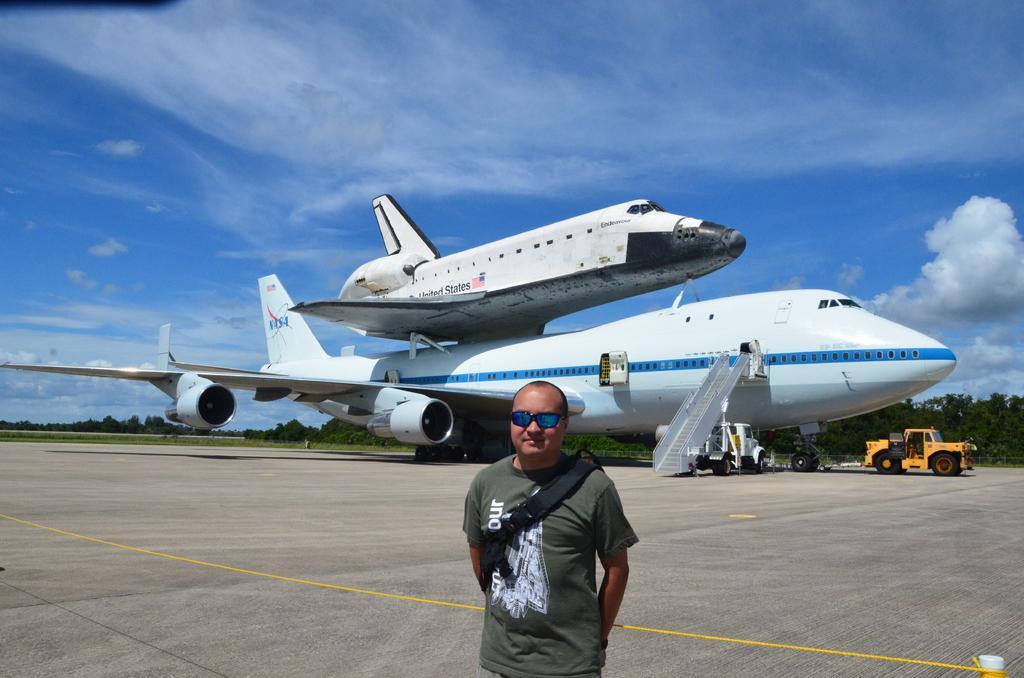In one or two sentences, can you explain what this image depicts? This image is taken outdoors. At the top of the image there is the sky with clouds. In the background there are a few trees and plants on the ground. There is a ground with grass on it. On the right side of the image a vehicle is parked on the runway. In the middle of the image there is an airplane and there is a jet airplane. There are few stairs and there is a vehicle parked on the runway. A man is standing. 